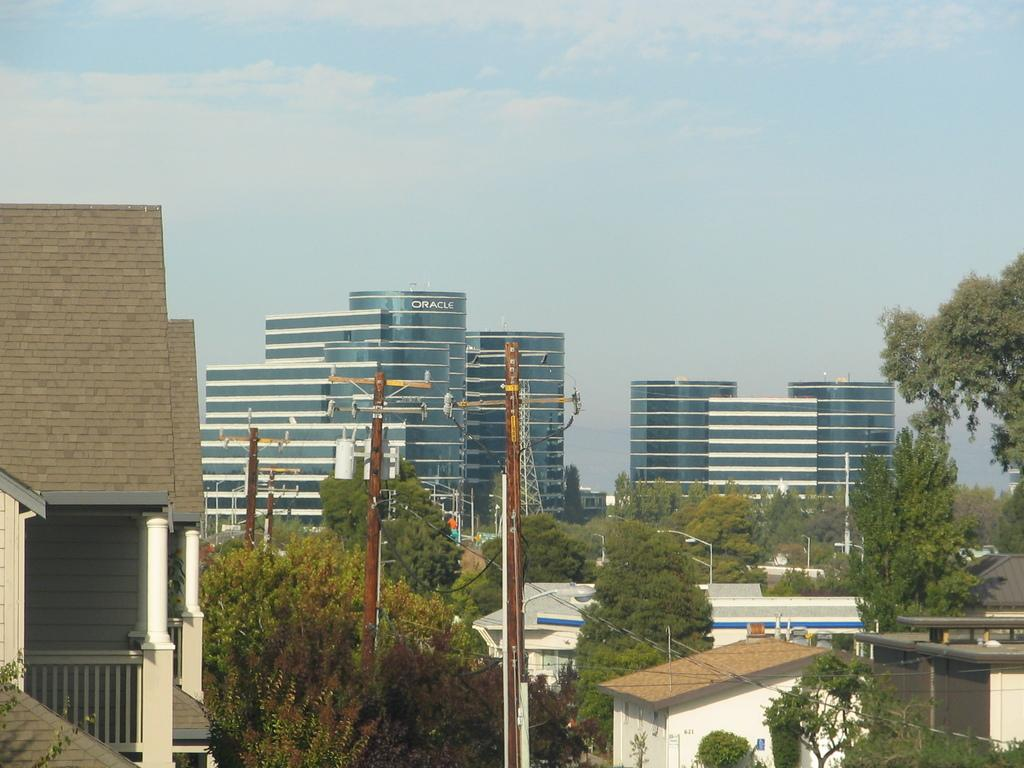<image>
Offer a succinct explanation of the picture presented. The Oracle building is shown in the distance behind the telephone poles and houses. 